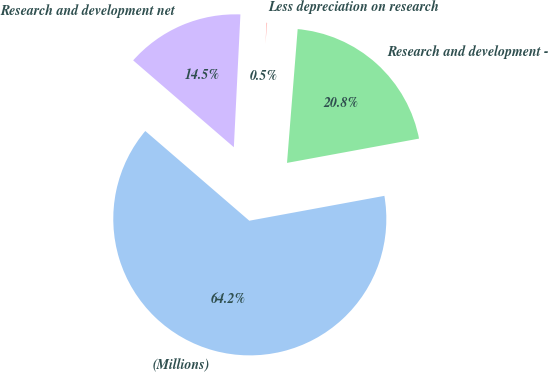Convert chart. <chart><loc_0><loc_0><loc_500><loc_500><pie_chart><fcel>(Millions)<fcel>Research and development -<fcel>Less depreciation on research<fcel>Research and development net<nl><fcel>64.23%<fcel>20.84%<fcel>0.48%<fcel>14.46%<nl></chart> 